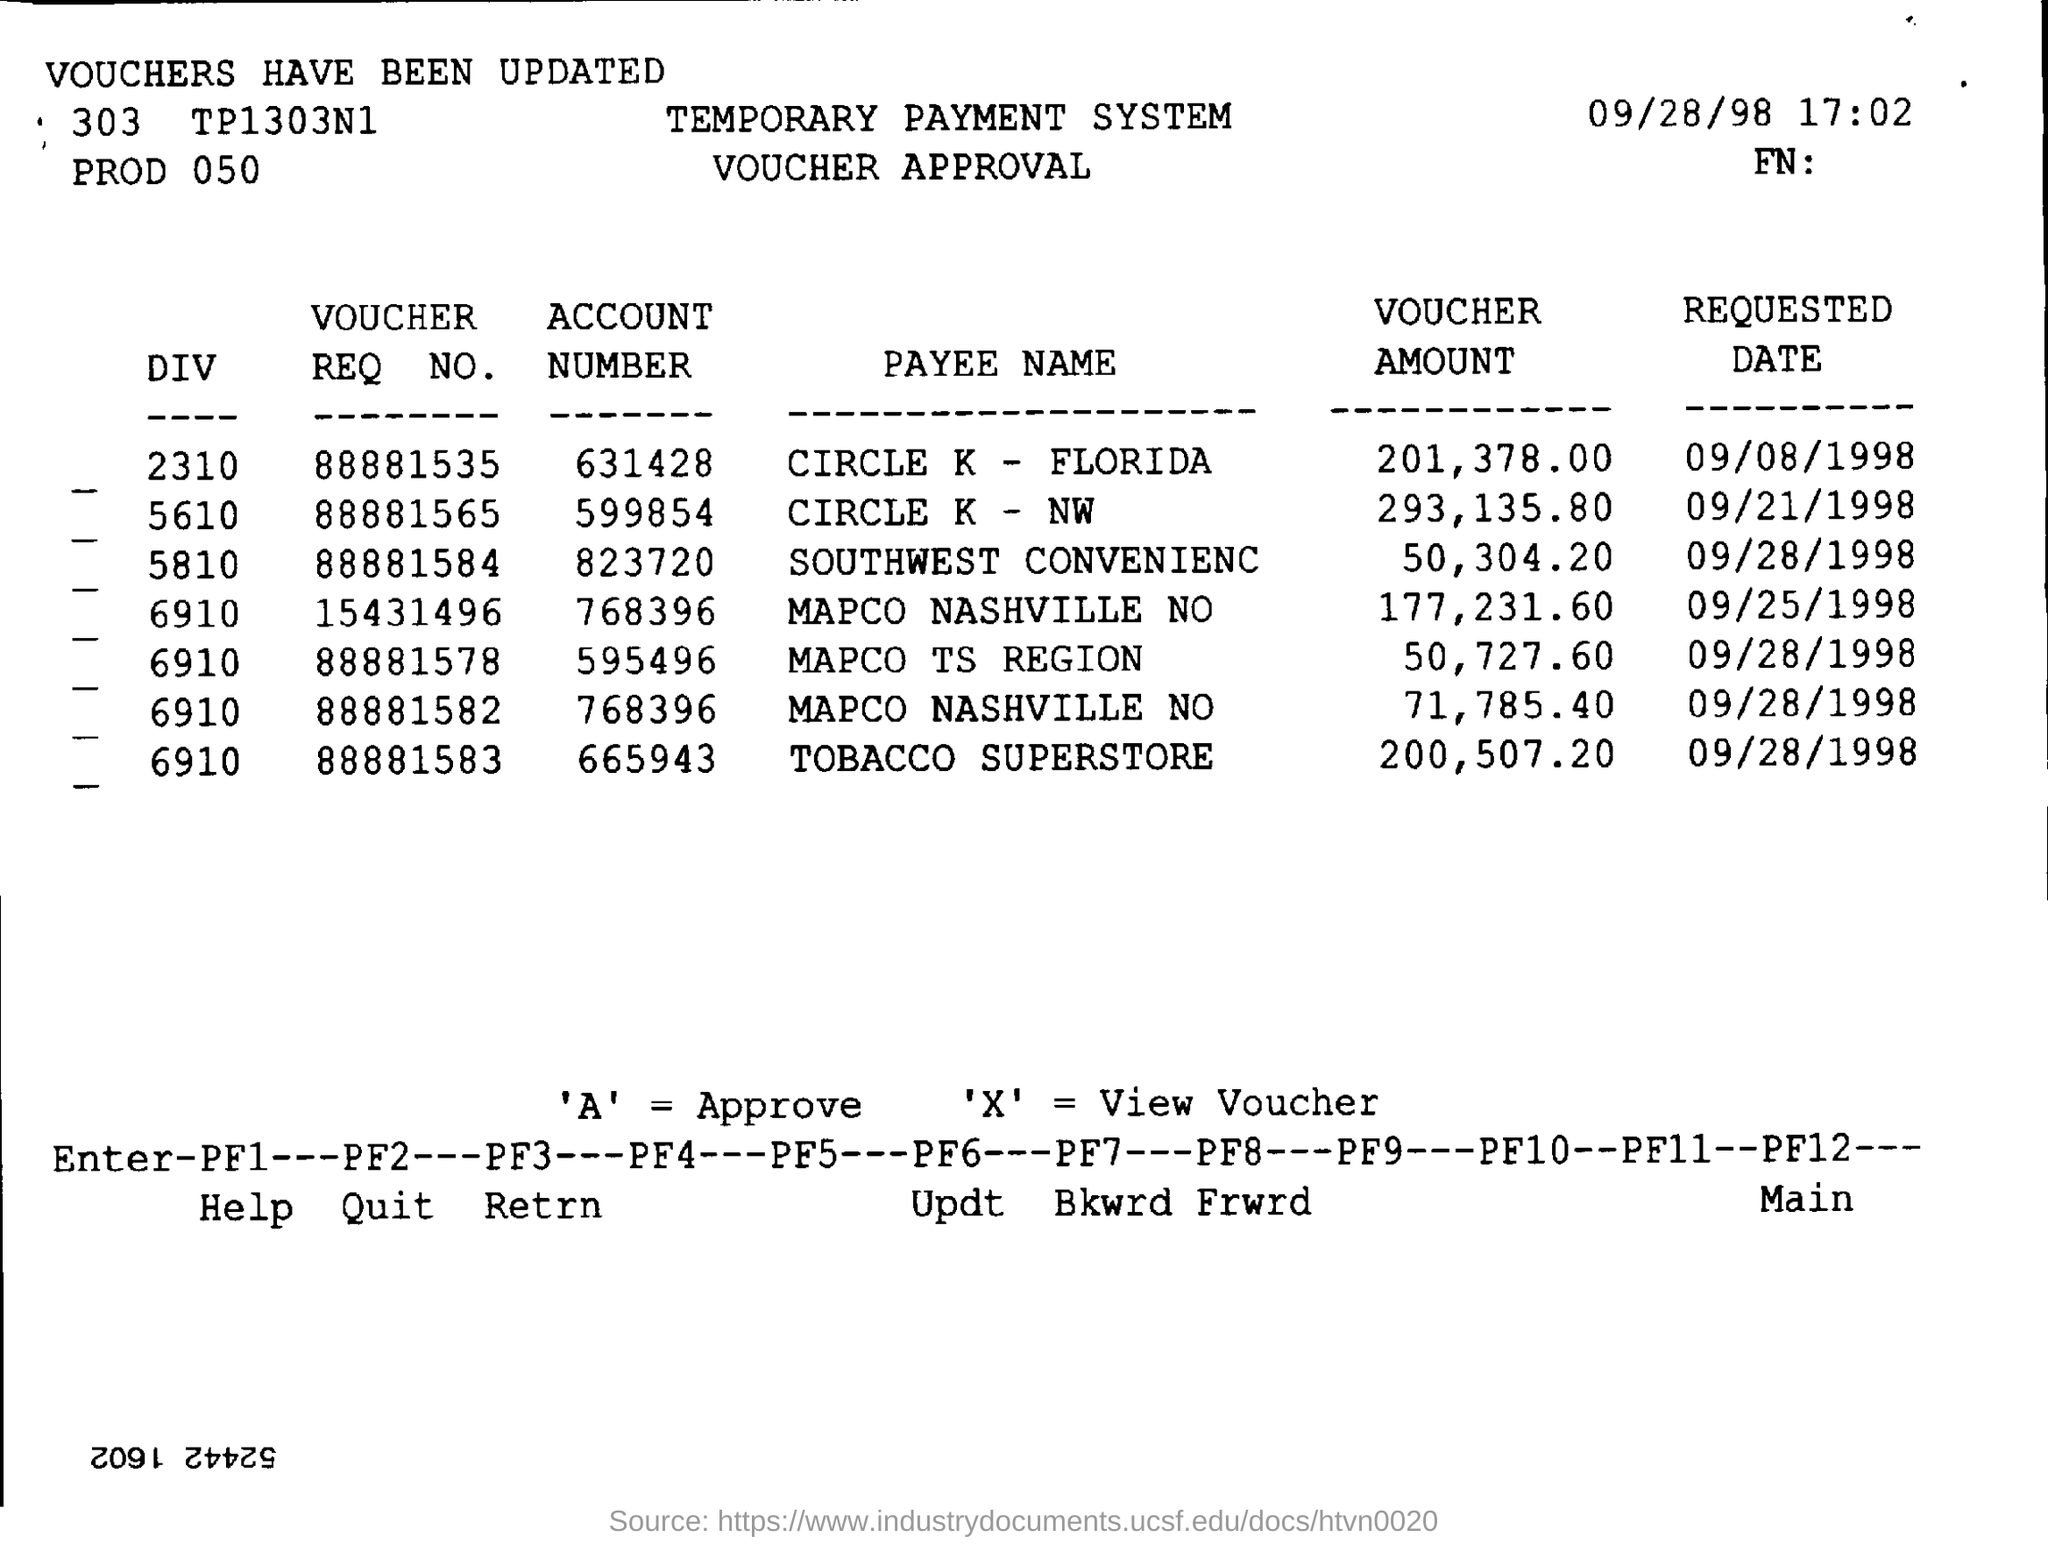Outline some significant characteristics in this image. On what date was the account number 599854 requested? Circle K, a company located in Florida, has an account number of 631428. I declare that 'A' indicates approval. The voucher amount for TOBACCO SUPERSTORE is 200,507.20. 